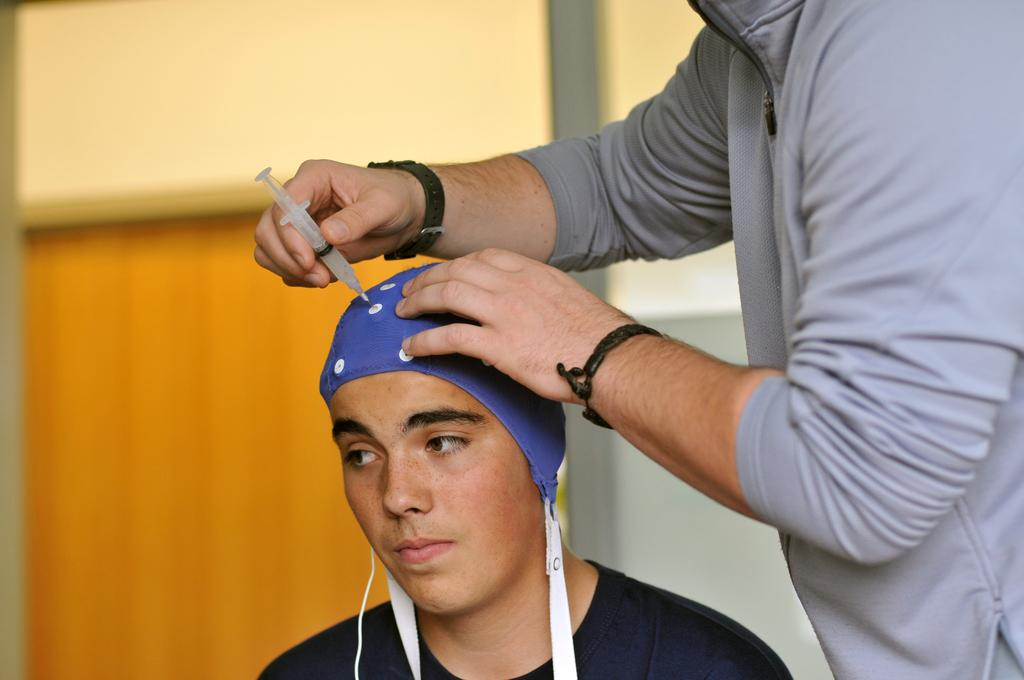How many people are in the image? There are two persons in the image. What is one of the persons holding? One of the persons is holding an injection. Can you describe the background of the image? The background of the image is blurred. What type of ticket is the person holding in the image? There is no ticket present in the image; one of the persons is holding an injection. How many chickens are visible in the image? There are no chickens present in the image. 